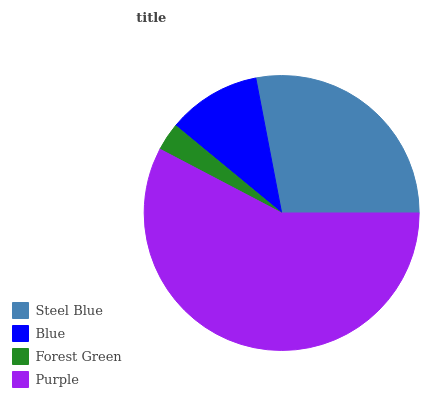Is Forest Green the minimum?
Answer yes or no. Yes. Is Purple the maximum?
Answer yes or no. Yes. Is Blue the minimum?
Answer yes or no. No. Is Blue the maximum?
Answer yes or no. No. Is Steel Blue greater than Blue?
Answer yes or no. Yes. Is Blue less than Steel Blue?
Answer yes or no. Yes. Is Blue greater than Steel Blue?
Answer yes or no. No. Is Steel Blue less than Blue?
Answer yes or no. No. Is Steel Blue the high median?
Answer yes or no. Yes. Is Blue the low median?
Answer yes or no. Yes. Is Purple the high median?
Answer yes or no. No. Is Forest Green the low median?
Answer yes or no. No. 